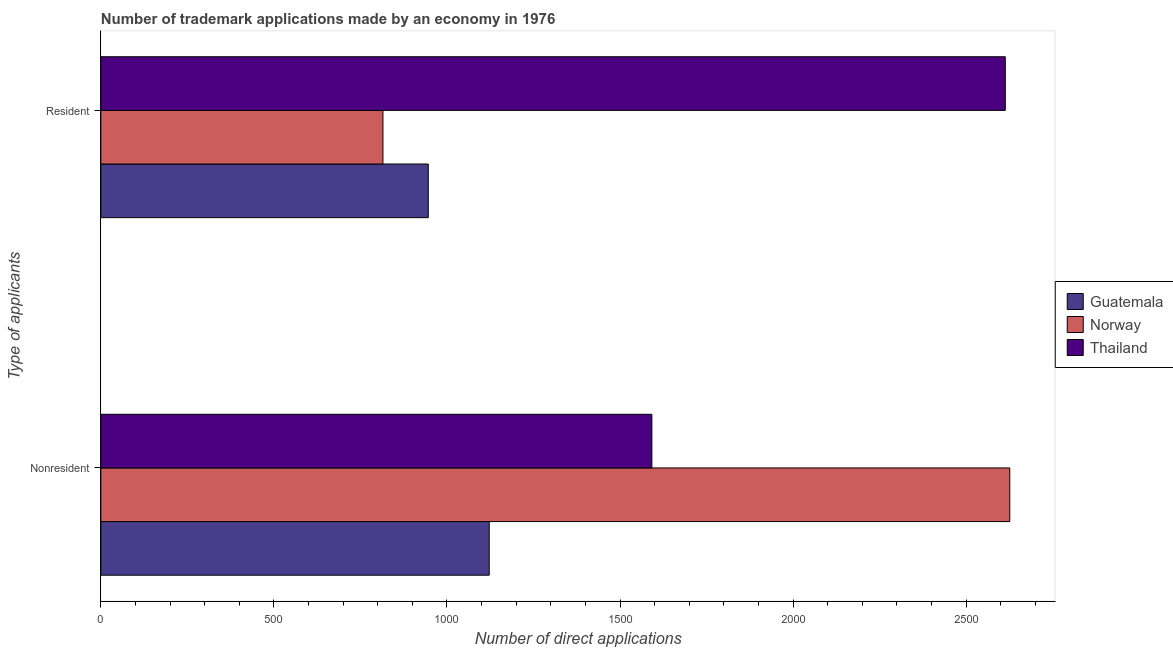How many different coloured bars are there?
Offer a very short reply. 3. How many groups of bars are there?
Keep it short and to the point. 2. How many bars are there on the 2nd tick from the top?
Provide a short and direct response. 3. What is the label of the 2nd group of bars from the top?
Offer a terse response. Nonresident. What is the number of trademark applications made by non residents in Thailand?
Ensure brevity in your answer.  1592. Across all countries, what is the maximum number of trademark applications made by non residents?
Give a very brief answer. 2626. Across all countries, what is the minimum number of trademark applications made by non residents?
Your answer should be compact. 1122. In which country was the number of trademark applications made by residents maximum?
Provide a succinct answer. Thailand. In which country was the number of trademark applications made by non residents minimum?
Provide a short and direct response. Guatemala. What is the total number of trademark applications made by residents in the graph?
Your answer should be very brief. 4374. What is the difference between the number of trademark applications made by residents in Guatemala and that in Thailand?
Give a very brief answer. -1667. What is the difference between the number of trademark applications made by non residents in Thailand and the number of trademark applications made by residents in Guatemala?
Keep it short and to the point. 646. What is the average number of trademark applications made by residents per country?
Your response must be concise. 1458. What is the difference between the number of trademark applications made by residents and number of trademark applications made by non residents in Guatemala?
Ensure brevity in your answer.  -176. In how many countries, is the number of trademark applications made by residents greater than 2200 ?
Keep it short and to the point. 1. What is the ratio of the number of trademark applications made by residents in Norway to that in Thailand?
Offer a very short reply. 0.31. What does the 1st bar from the top in Nonresident represents?
Make the answer very short. Thailand. What does the 3rd bar from the bottom in Nonresident represents?
Make the answer very short. Thailand. How many countries are there in the graph?
Give a very brief answer. 3. Does the graph contain grids?
Provide a succinct answer. No. Where does the legend appear in the graph?
Provide a succinct answer. Center right. How are the legend labels stacked?
Offer a very short reply. Vertical. What is the title of the graph?
Give a very brief answer. Number of trademark applications made by an economy in 1976. Does "Burkina Faso" appear as one of the legend labels in the graph?
Your answer should be compact. No. What is the label or title of the X-axis?
Keep it short and to the point. Number of direct applications. What is the label or title of the Y-axis?
Make the answer very short. Type of applicants. What is the Number of direct applications of Guatemala in Nonresident?
Provide a succinct answer. 1122. What is the Number of direct applications of Norway in Nonresident?
Offer a very short reply. 2626. What is the Number of direct applications of Thailand in Nonresident?
Provide a short and direct response. 1592. What is the Number of direct applications in Guatemala in Resident?
Your answer should be compact. 946. What is the Number of direct applications of Norway in Resident?
Provide a short and direct response. 815. What is the Number of direct applications in Thailand in Resident?
Make the answer very short. 2613. Across all Type of applicants, what is the maximum Number of direct applications in Guatemala?
Offer a very short reply. 1122. Across all Type of applicants, what is the maximum Number of direct applications in Norway?
Provide a succinct answer. 2626. Across all Type of applicants, what is the maximum Number of direct applications of Thailand?
Ensure brevity in your answer.  2613. Across all Type of applicants, what is the minimum Number of direct applications of Guatemala?
Offer a terse response. 946. Across all Type of applicants, what is the minimum Number of direct applications of Norway?
Your response must be concise. 815. Across all Type of applicants, what is the minimum Number of direct applications of Thailand?
Your answer should be very brief. 1592. What is the total Number of direct applications of Guatemala in the graph?
Give a very brief answer. 2068. What is the total Number of direct applications in Norway in the graph?
Your answer should be very brief. 3441. What is the total Number of direct applications of Thailand in the graph?
Offer a very short reply. 4205. What is the difference between the Number of direct applications of Guatemala in Nonresident and that in Resident?
Offer a terse response. 176. What is the difference between the Number of direct applications of Norway in Nonresident and that in Resident?
Offer a very short reply. 1811. What is the difference between the Number of direct applications in Thailand in Nonresident and that in Resident?
Keep it short and to the point. -1021. What is the difference between the Number of direct applications in Guatemala in Nonresident and the Number of direct applications in Norway in Resident?
Provide a short and direct response. 307. What is the difference between the Number of direct applications of Guatemala in Nonresident and the Number of direct applications of Thailand in Resident?
Make the answer very short. -1491. What is the difference between the Number of direct applications of Norway in Nonresident and the Number of direct applications of Thailand in Resident?
Offer a very short reply. 13. What is the average Number of direct applications in Guatemala per Type of applicants?
Give a very brief answer. 1034. What is the average Number of direct applications in Norway per Type of applicants?
Your response must be concise. 1720.5. What is the average Number of direct applications in Thailand per Type of applicants?
Your response must be concise. 2102.5. What is the difference between the Number of direct applications in Guatemala and Number of direct applications in Norway in Nonresident?
Your answer should be very brief. -1504. What is the difference between the Number of direct applications in Guatemala and Number of direct applications in Thailand in Nonresident?
Make the answer very short. -470. What is the difference between the Number of direct applications in Norway and Number of direct applications in Thailand in Nonresident?
Provide a short and direct response. 1034. What is the difference between the Number of direct applications in Guatemala and Number of direct applications in Norway in Resident?
Provide a succinct answer. 131. What is the difference between the Number of direct applications in Guatemala and Number of direct applications in Thailand in Resident?
Provide a succinct answer. -1667. What is the difference between the Number of direct applications in Norway and Number of direct applications in Thailand in Resident?
Your answer should be very brief. -1798. What is the ratio of the Number of direct applications in Guatemala in Nonresident to that in Resident?
Provide a short and direct response. 1.19. What is the ratio of the Number of direct applications in Norway in Nonresident to that in Resident?
Ensure brevity in your answer.  3.22. What is the ratio of the Number of direct applications in Thailand in Nonresident to that in Resident?
Provide a short and direct response. 0.61. What is the difference between the highest and the second highest Number of direct applications in Guatemala?
Your answer should be very brief. 176. What is the difference between the highest and the second highest Number of direct applications in Norway?
Provide a succinct answer. 1811. What is the difference between the highest and the second highest Number of direct applications of Thailand?
Your answer should be very brief. 1021. What is the difference between the highest and the lowest Number of direct applications in Guatemala?
Offer a very short reply. 176. What is the difference between the highest and the lowest Number of direct applications of Norway?
Offer a very short reply. 1811. What is the difference between the highest and the lowest Number of direct applications in Thailand?
Provide a short and direct response. 1021. 